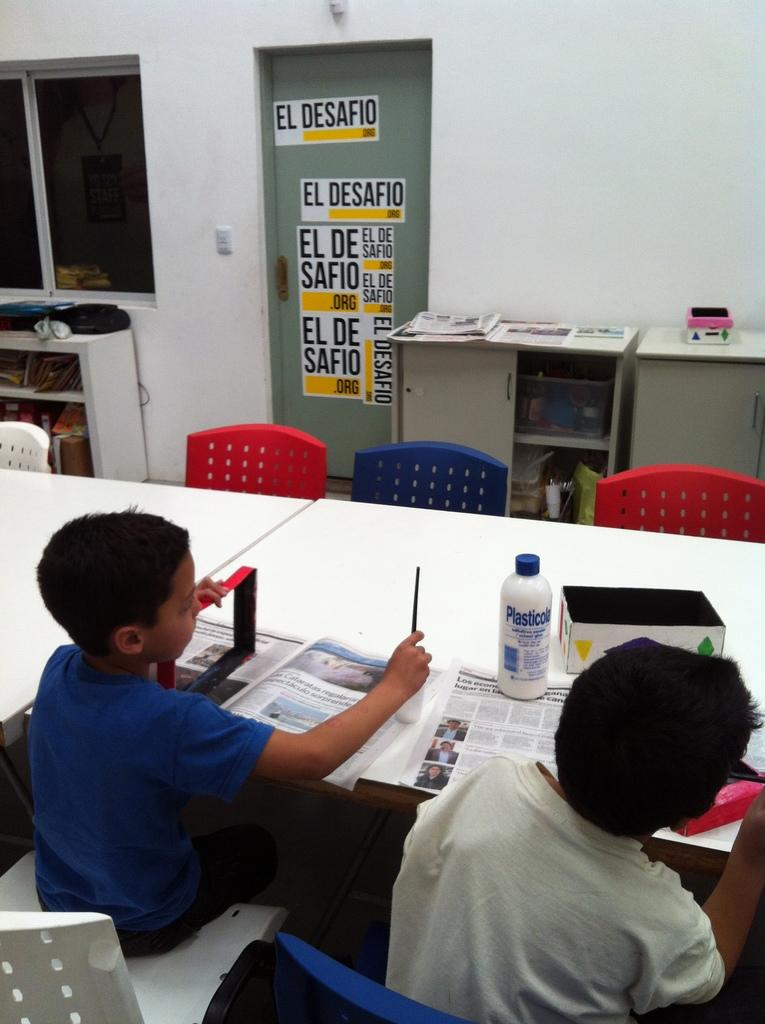<image>
Relay a brief, clear account of the picture shown. Two boys sit at a table in a room with a door covered in El Desafio labels in the background. 